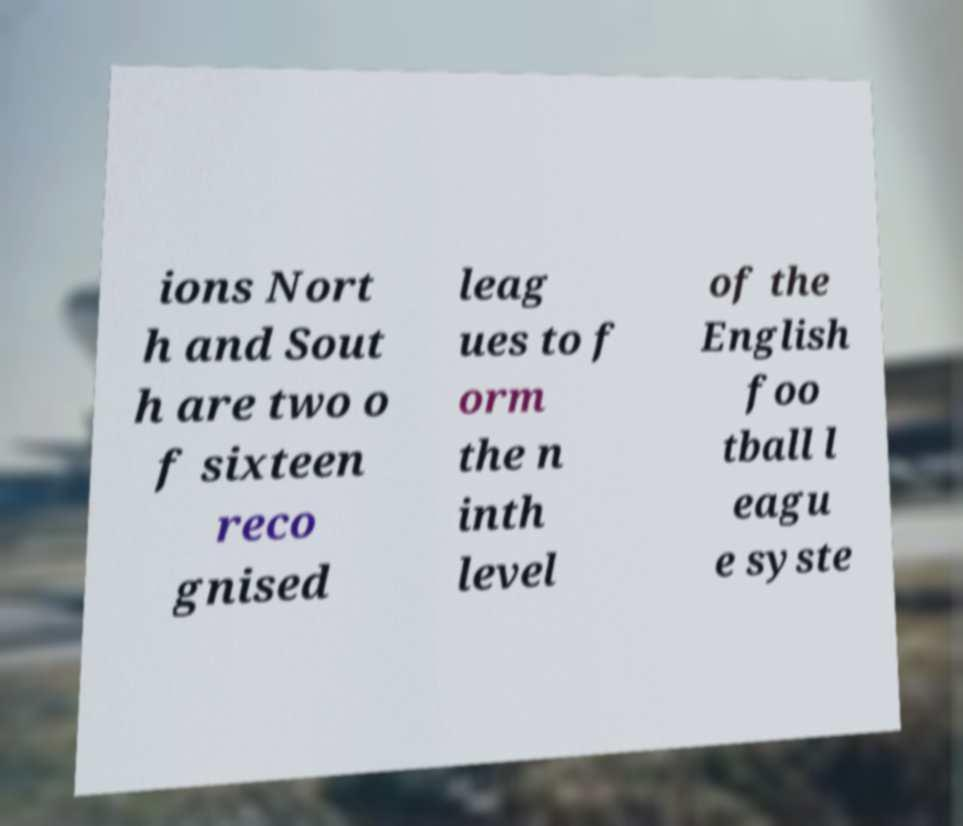I need the written content from this picture converted into text. Can you do that? ions Nort h and Sout h are two o f sixteen reco gnised leag ues to f orm the n inth level of the English foo tball l eagu e syste 